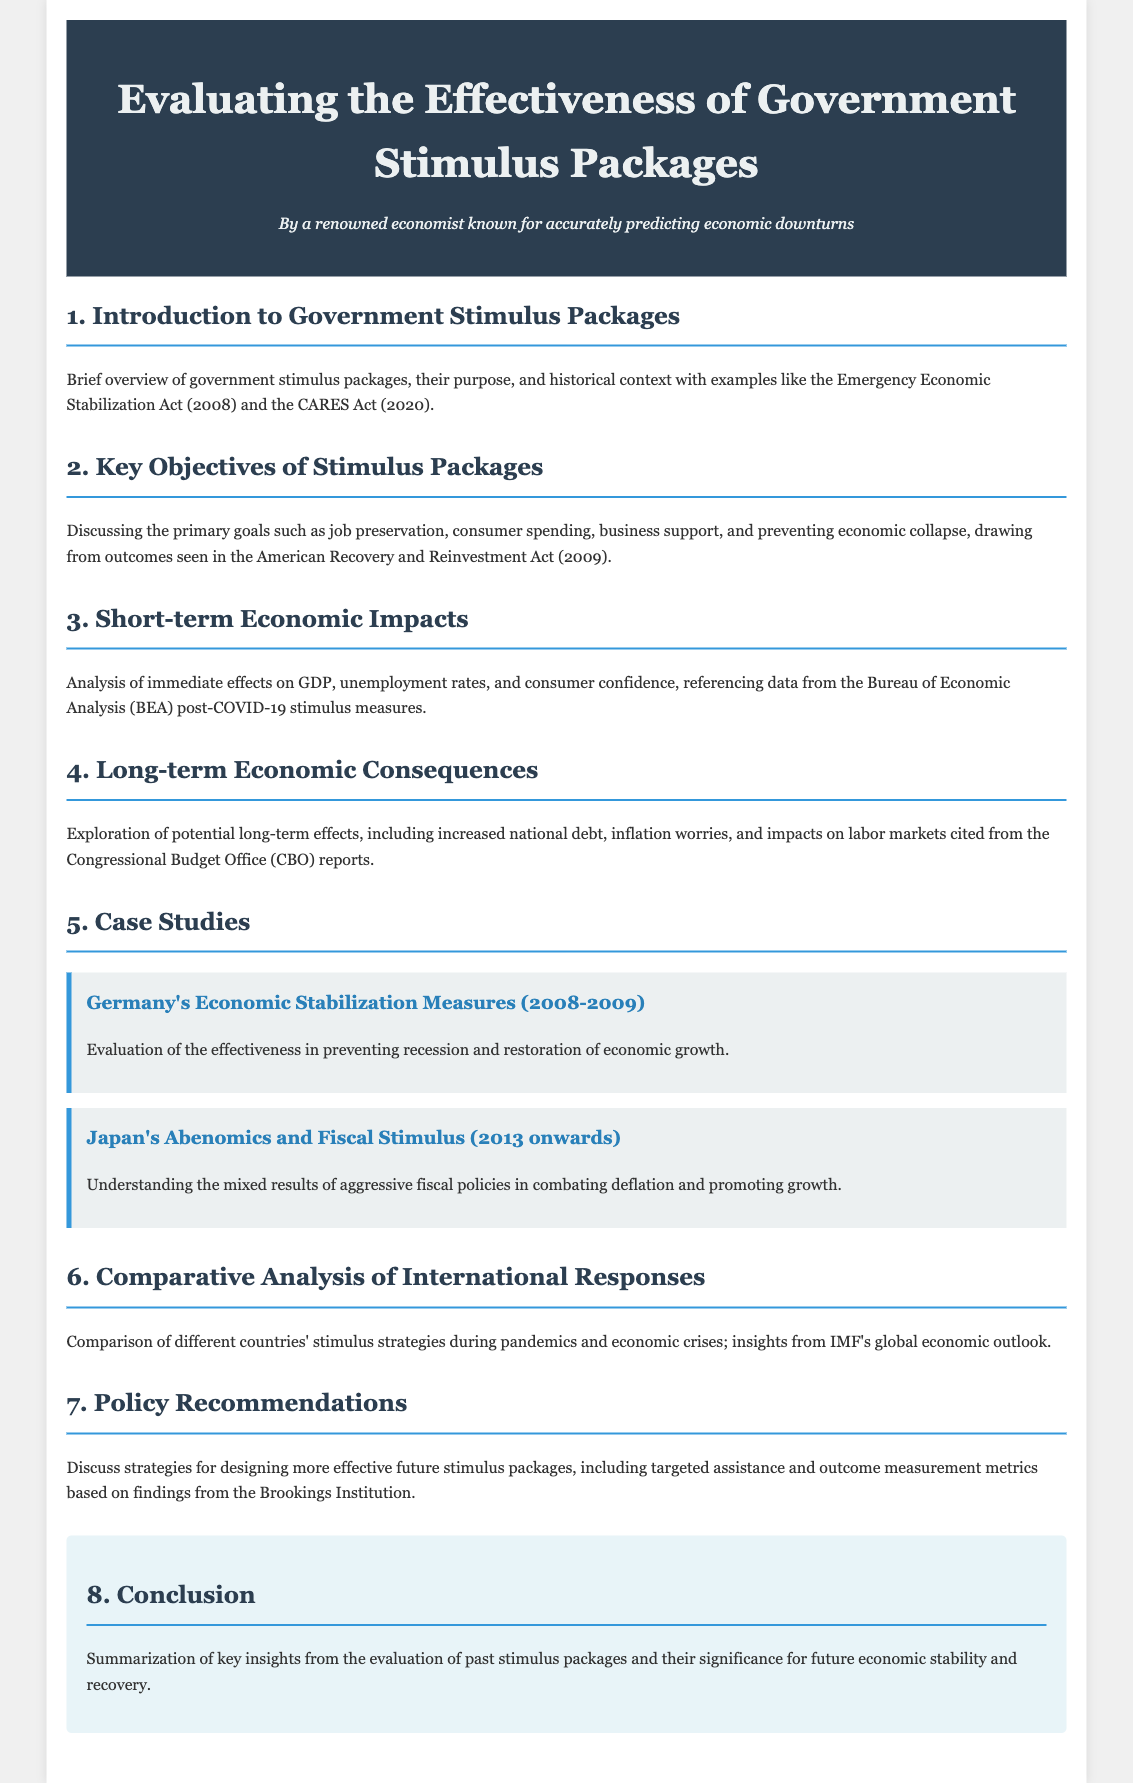What is the purpose of government stimulus packages? The purpose of government stimulus packages is outlined in the introduction, focusing on preventing economic collapse and supporting the economy during crises.
Answer: Preventing economic collapse What act is mentioned as an example from 2008? The Emergency Economic Stabilization Act is referenced as a historical example of a government stimulus package from 2008.
Answer: Emergency Economic Stabilization Act What was one of the primary objectives of the stimulus packages? One key objective discussed is job preservation, which highlights the focus of these packages on maintaining employment.
Answer: Job preservation In which year did the American Recovery and Reinvestment Act take place? The American Recovery and Reinvestment Act is mentioned in the context of 2009, indicating its implementation during that year.
Answer: 2009 Which country’s economic stabilization measures from 2008-2009 are evaluated in a case study? Germany's Economic Stabilization Measures are presented as a case study for evaluation.
Answer: Germany What does the document suggest about potential long-term consequences relating to the national debt? It indicates that the evaluation explores concerns regarding increased national debt as a long-term consequence of stimulus packages.
Answer: Increased national debt From which organization are insights cited in the comparative analysis of international responses? Insights in the comparative analysis are cited from the International Monetary Fund (IMF).
Answer: International Monetary Fund (IMF) What type of recommendations are discussed for future stimulus packages? The document discusses strategies for policy recommendations aimed at designing more effective future stimulus packages.
Answer: Policy recommendations 